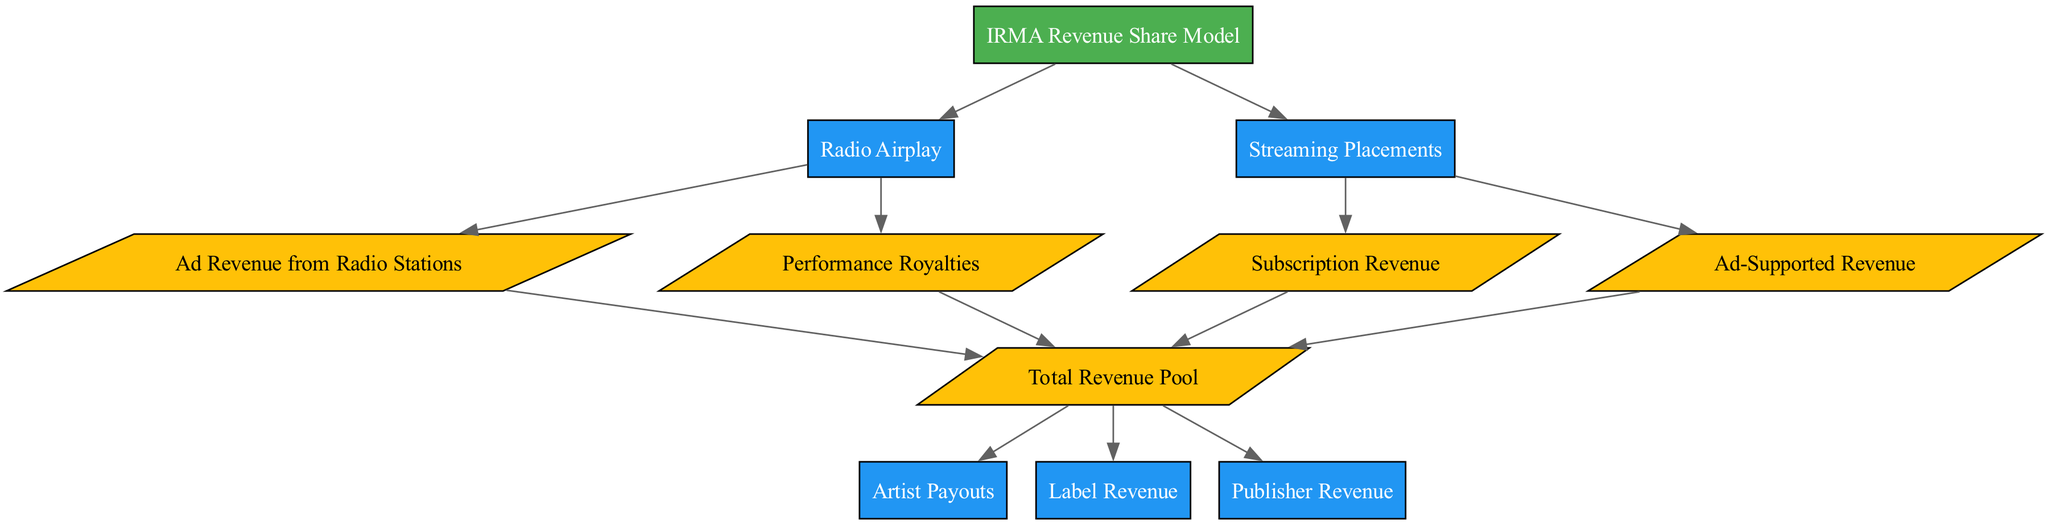What is the main model depicted in the diagram? The root of the diagram identifies the main component, which is labeled as "IRMA Revenue Share Model."
Answer: IRMA Revenue Share Model How many data nodes are present in the diagram? Count the nodes categorized as "data." There are four identified data nodes: "Ad Revenue from Radio Stations," "Performance Royalties," "Subscription Revenue," and "Ad-Supported Revenue."
Answer: 4 What connects Radio Airplay to Total Revenue Pool? "Radio Airplay" is connected to two nodes: "Ad Revenue from Radio Stations" and "Performance Royalties," both of which lead to "Total Revenue Pool."
Answer: Ad Revenue from Radio Stations, Performance Royalties Which type of revenue supports the Streaming Placements process? Streaming Placements connect to "Subscription Revenue" and "Ad-Supported Revenue," both contributing to the overall revenue pool.
Answer: Subscription Revenue, Ad-Supported Revenue What processes are influenced by the Total Revenue Pool? The Total Revenue Pool branches out to three processes: "Artist Payouts," "Label Revenue," and "Publisher Revenue."
Answer: Artist Payouts, Label Revenue, Publisher Revenue How many connections lead from the IRMA Revenue Share Model? There are two connections leading from "IRMA Revenue Share Model," which connect it to "Radio Airplay" and "Streaming Placements."
Answer: 2 What is the relationship between the Radio Airplay and Streaming Placements? Both are processes that contribute to the same overall revenue mechanism depicted in the diagram, but they operate through different types of revenue sources.
Answer: Both contribute to Total Revenue Pool Which node is the last in the flow for artist remuneration? The node "Artist Payouts" is the last process that depicts how the revenues are allocated to artists after pooling.
Answer: Artist Payouts 